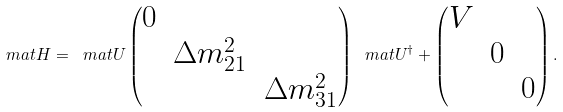Convert formula to latex. <formula><loc_0><loc_0><loc_500><loc_500>\ m a t { H } = \ m a t { U } \begin{pmatrix} 0 & & \\ & \Delta m _ { 2 1 } ^ { 2 } & \\ & & \Delta m _ { 3 1 } ^ { 2 } \end{pmatrix} \ m a t { U } ^ { \dag } + \begin{pmatrix} V & & \\ & 0 & \\ & & 0 \end{pmatrix} .</formula> 